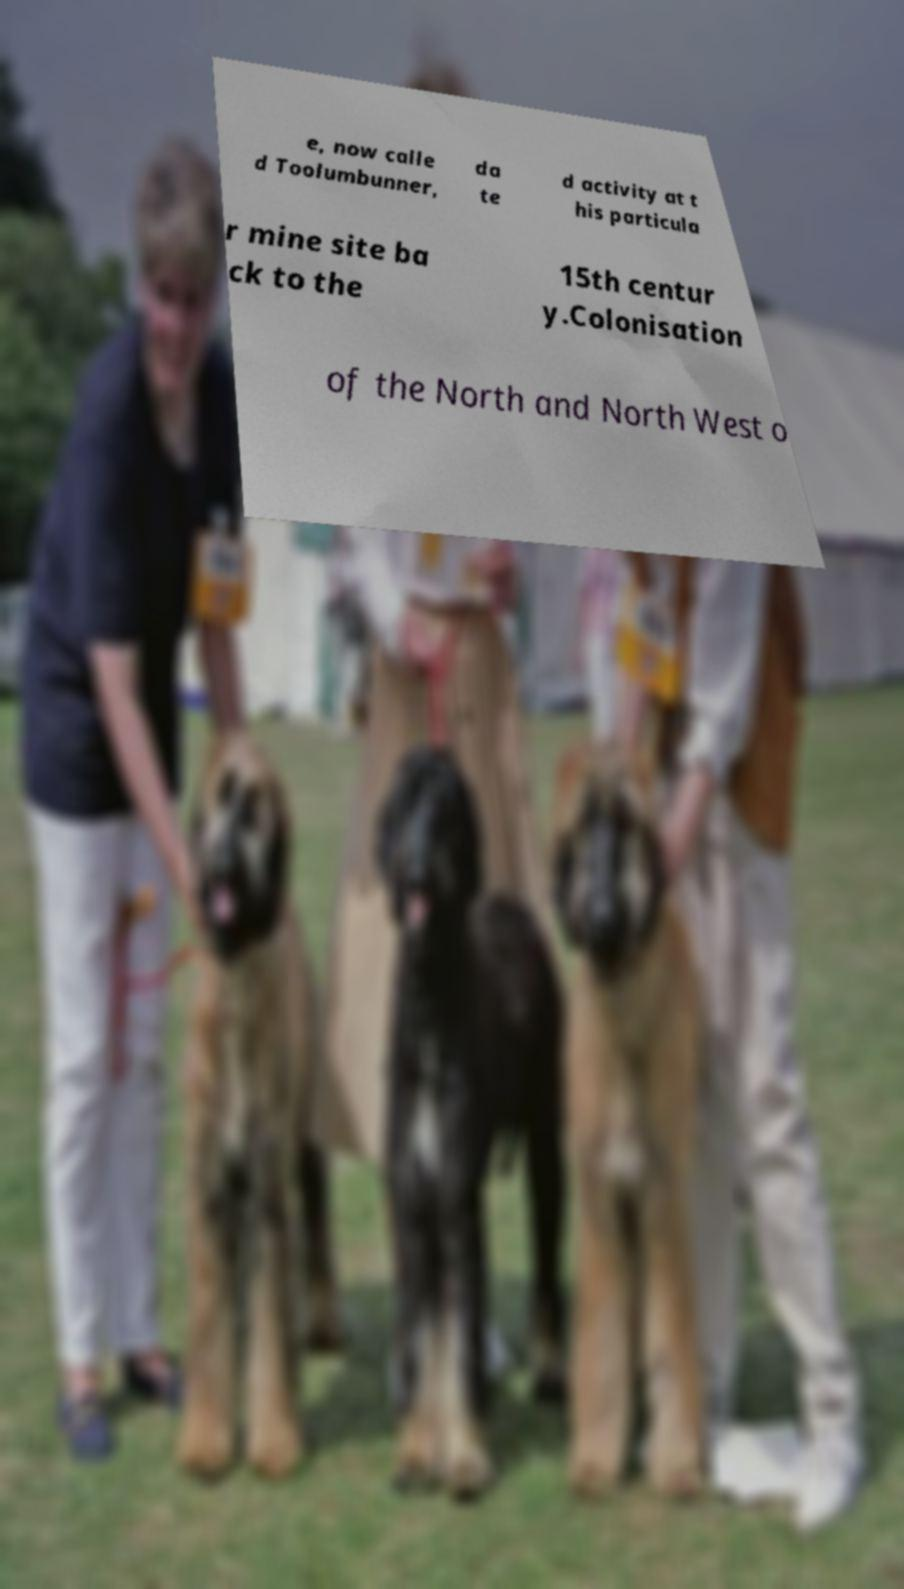Please read and relay the text visible in this image. What does it say? e, now calle d Toolumbunner, da te d activity at t his particula r mine site ba ck to the 15th centur y.Colonisation of the North and North West o 